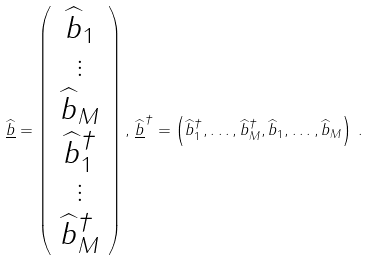<formula> <loc_0><loc_0><loc_500><loc_500>\underline { \widehat { b } } = \left ( \begin{array} { c } \widehat { b } _ { 1 } \\ \vdots \\ \widehat { b } _ { M } \\ \widehat { b } _ { 1 } ^ { \dagger } \\ \vdots \\ \widehat { b } _ { M } ^ { \dagger } \end{array} \right ) , \, \underline { \widehat { b } } ^ { \dagger } = \left ( \widehat { b } _ { 1 } ^ { \dagger } , \dots , \widehat { b } _ { M } ^ { \dagger } , \widehat { b } _ { 1 } , \dots , \widehat { b } _ { M } \right ) \, .</formula> 